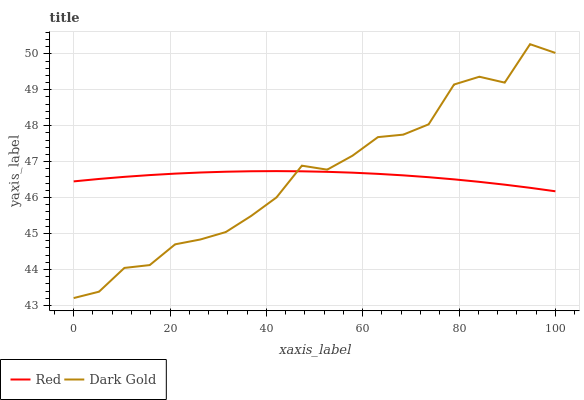Does Dark Gold have the minimum area under the curve?
Answer yes or no. No. Is Dark Gold the smoothest?
Answer yes or no. No. 